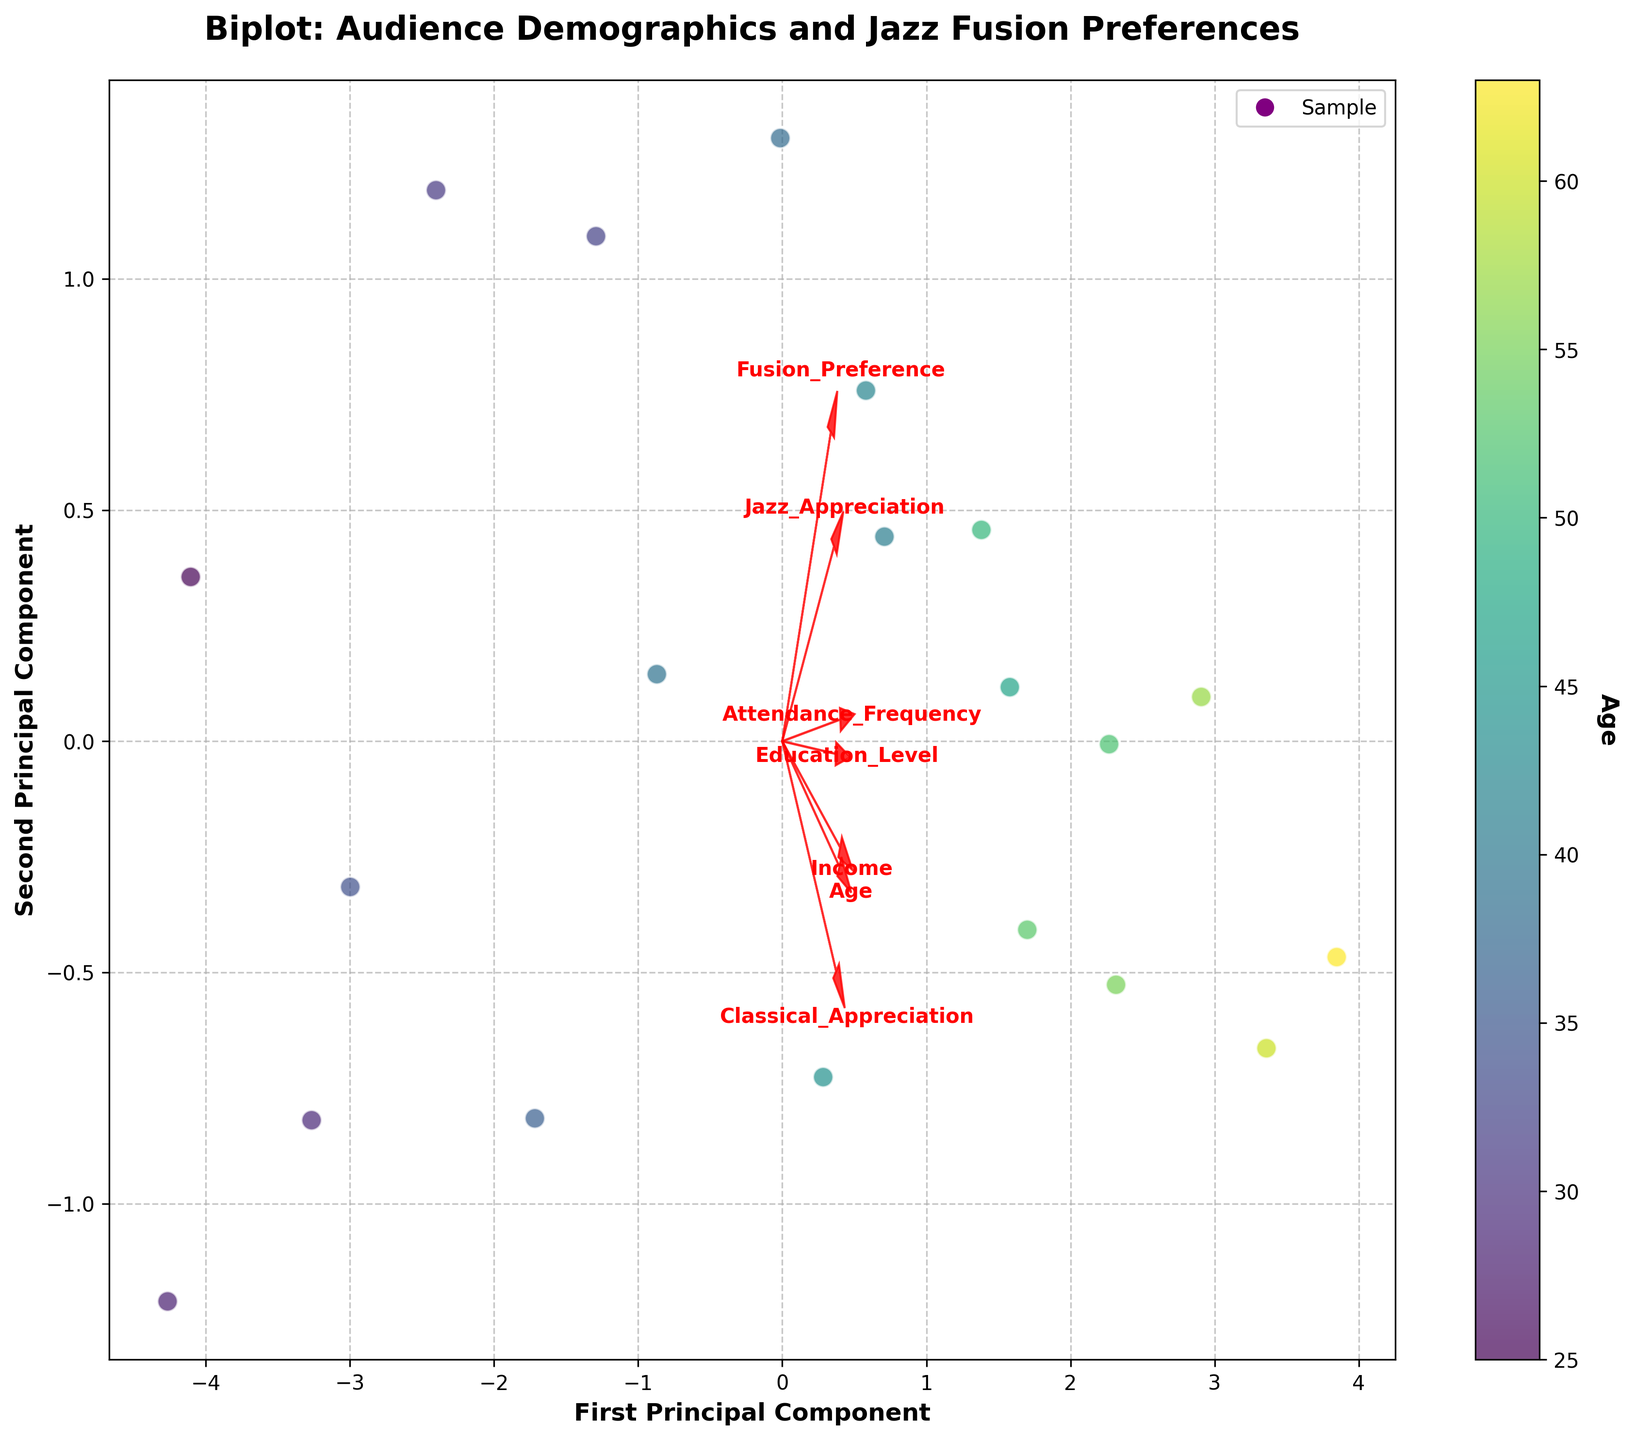What does the title of the plot indicate? The title of the plot "Biplot: Audience Demographics and Jazz Fusion Preferences" indicates that the plot visualizes the relationship between audience demographics and their preferences for jazz fusion performances.
Answer: Relationships between demographics and preferences What do the arrows represent in the biplot? The arrows represent the feature vectors of the audience characteristics such as Age, Income, Education_Level, Jazz_Appreciation, Classical_Appreciation, Fusion_Preference, and Attendance_Frequency. The direction and length of each arrow indicate how strongly each feature contributes to the two principal components.
Answer: Feature contributions How are age and attendance frequency correlated based on the biplot? In the biplot, the vectors for Age and Attendance_Frequency are pointing in similar directions, indicating that these two features are positively correlated. This means that, generally, as age increases, the attendance frequency also increases.
Answer: Positively correlated Which feature is most closely aligned with the first principal component? The feature vector "Income" is most closely aligned with the first principal component (x-axis) as it points directly along this axis, indicating that income has the highest contribution to the first principal component.
Answer: Income How do Jazz Appreciation and Fusion Preference vectors relate to each other? The Jazz_Appreciation and Fusion_Preference vectors are pointing in the same general direction, indicating a positive correlation. This suggests that those who appreciate jazz music are also likely to have a preference for fusion performances.
Answer: Positively correlated In the biplot, which age group prefers fusion performances the most? The color bar on the plot shows age with darker colors indicating older ages. The points with darker shades are located near higher values on the Fusion_Preference vector, suggesting older age groups have a higher preference for fusion performances.
Answer: Older age groups How does Education Level correlate with Classical Appreciation? The vectors for Education_Level and Classical_Appreciation are pointing in similar directions, indicating a positive correlation. This suggests that higher education levels are associated with a greater appreciation for classical music.
Answer: Positively correlated What can you infer about the association between Income and Attendance Frequency? The vectors for Income and Attendance_Frequency are pointing in similar directions and are roughly aligned, indicating a positive correlation. This means that higher income is associated with higher attendance frequency at jazz fusion performances.
Answer: Positively correlated Are the vectors for Age and Jazz Appreciation closely aligned? The vectors for Age and Jazz_Appreciation are not closely aligned; they are pointing in slightly different directions, indicating a weaker or more complex relationship between age and appreciation for jazz music.
Answer: Weak or complex relationship 